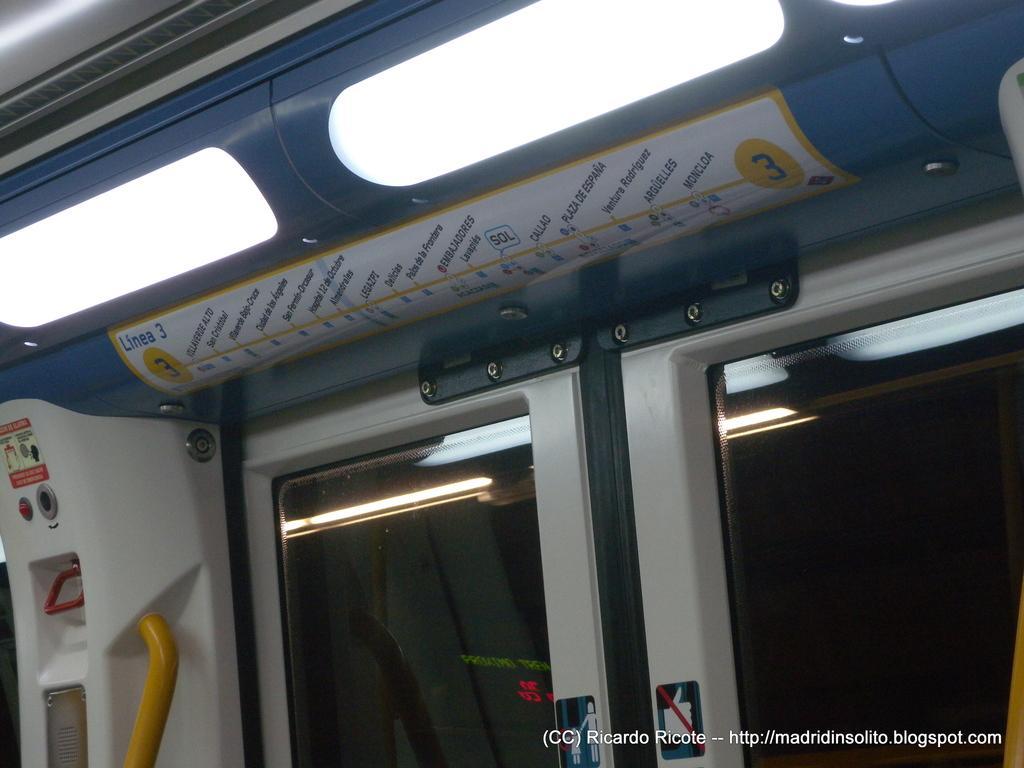Describe this image in one or two sentences. This picture is taken from inside a metro train, on the right side there are doors, at the top there is a map and lights, in the bottom right there is text. 